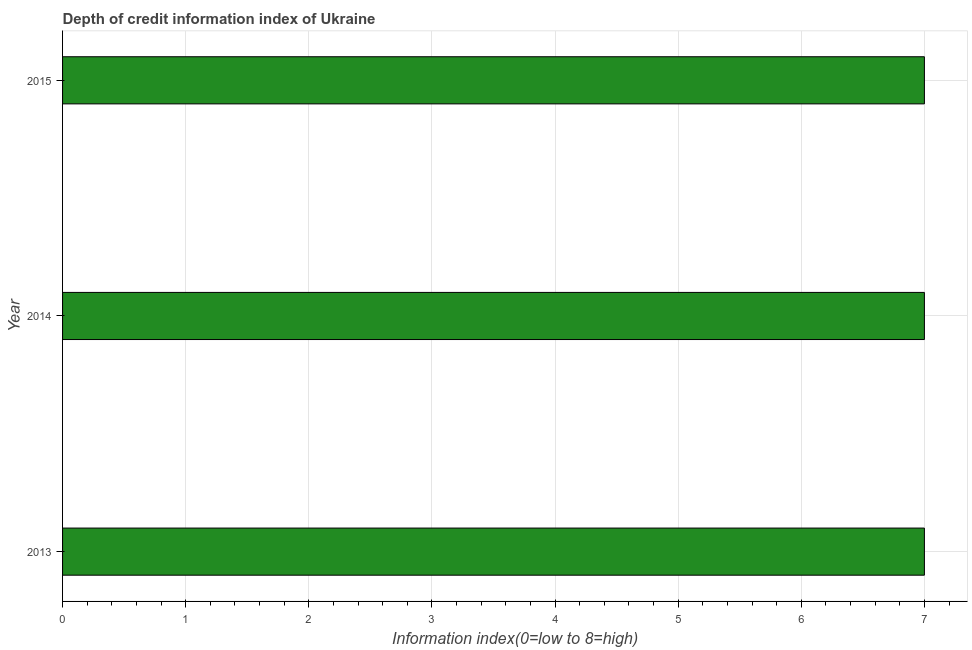Does the graph contain grids?
Your response must be concise. Yes. What is the title of the graph?
Offer a very short reply. Depth of credit information index of Ukraine. What is the label or title of the X-axis?
Offer a terse response. Information index(0=low to 8=high). What is the label or title of the Y-axis?
Make the answer very short. Year. What is the depth of credit information index in 2015?
Your response must be concise. 7. Across all years, what is the maximum depth of credit information index?
Offer a very short reply. 7. In which year was the depth of credit information index maximum?
Ensure brevity in your answer.  2013. What is the difference between the depth of credit information index in 2013 and 2015?
Make the answer very short. 0. What is the average depth of credit information index per year?
Ensure brevity in your answer.  7. What is the median depth of credit information index?
Make the answer very short. 7. In how many years, is the depth of credit information index greater than 1.8 ?
Offer a very short reply. 3. What is the ratio of the depth of credit information index in 2014 to that in 2015?
Provide a short and direct response. 1. What is the difference between the highest and the second highest depth of credit information index?
Your answer should be very brief. 0. Is the sum of the depth of credit information index in 2013 and 2015 greater than the maximum depth of credit information index across all years?
Offer a terse response. Yes. What is the difference between the highest and the lowest depth of credit information index?
Ensure brevity in your answer.  0. In how many years, is the depth of credit information index greater than the average depth of credit information index taken over all years?
Your response must be concise. 0. How many bars are there?
Your response must be concise. 3. How many years are there in the graph?
Offer a very short reply. 3. What is the difference between two consecutive major ticks on the X-axis?
Your answer should be compact. 1. Are the values on the major ticks of X-axis written in scientific E-notation?
Your answer should be compact. No. What is the Information index(0=low to 8=high) of 2013?
Offer a very short reply. 7. What is the Information index(0=low to 8=high) of 2015?
Give a very brief answer. 7. What is the difference between the Information index(0=low to 8=high) in 2013 and 2014?
Offer a terse response. 0. What is the ratio of the Information index(0=low to 8=high) in 2013 to that in 2015?
Your answer should be compact. 1. What is the ratio of the Information index(0=low to 8=high) in 2014 to that in 2015?
Your response must be concise. 1. 